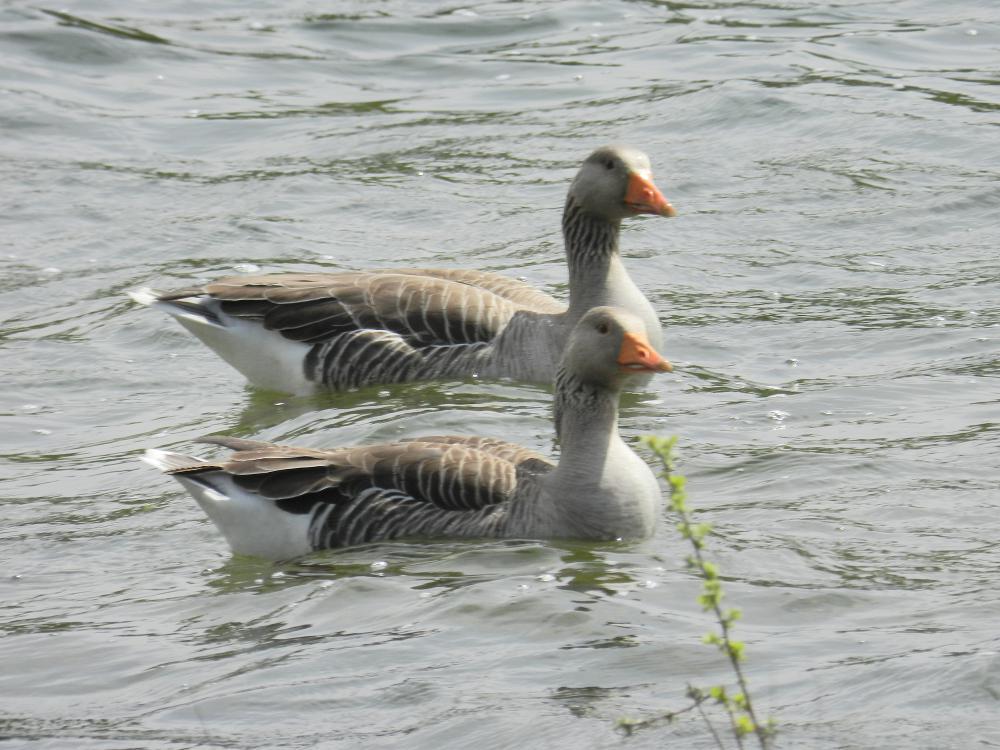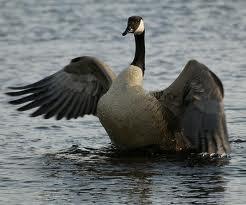The first image is the image on the left, the second image is the image on the right. Evaluate the accuracy of this statement regarding the images: "Two geese are floating on the water in the image on the left.". Is it true? Answer yes or no. Yes. 